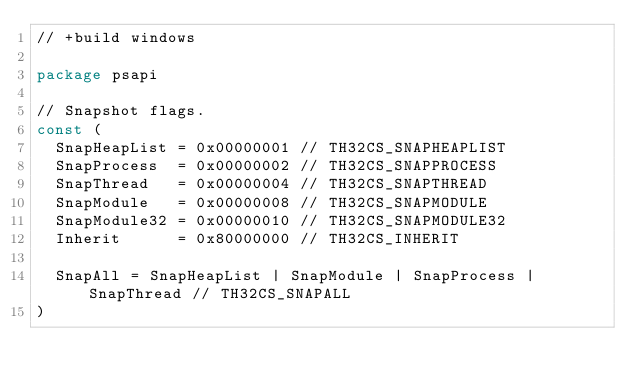<code> <loc_0><loc_0><loc_500><loc_500><_Go_>// +build windows

package psapi

// Snapshot flags.
const (
	SnapHeapList = 0x00000001 // TH32CS_SNAPHEAPLIST
	SnapProcess  = 0x00000002 // TH32CS_SNAPPROCESS
	SnapThread   = 0x00000004 // TH32CS_SNAPTHREAD
	SnapModule   = 0x00000008 // TH32CS_SNAPMODULE
	SnapModule32 = 0x00000010 // TH32CS_SNAPMODULE32
	Inherit      = 0x80000000 // TH32CS_INHERIT

	SnapAll = SnapHeapList | SnapModule | SnapProcess | SnapThread // TH32CS_SNAPALL
)
</code> 